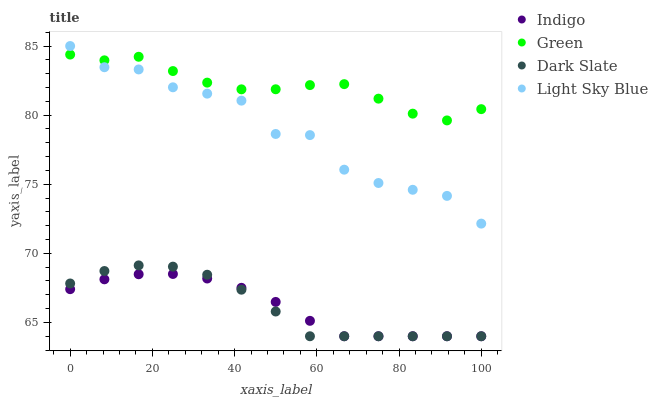Does Indigo have the minimum area under the curve?
Answer yes or no. Yes. Does Green have the maximum area under the curve?
Answer yes or no. Yes. Does Light Sky Blue have the minimum area under the curve?
Answer yes or no. No. Does Light Sky Blue have the maximum area under the curve?
Answer yes or no. No. Is Indigo the smoothest?
Answer yes or no. Yes. Is Light Sky Blue the roughest?
Answer yes or no. Yes. Is Light Sky Blue the smoothest?
Answer yes or no. No. Is Indigo the roughest?
Answer yes or no. No. Does Indigo have the lowest value?
Answer yes or no. Yes. Does Light Sky Blue have the lowest value?
Answer yes or no. No. Does Light Sky Blue have the highest value?
Answer yes or no. Yes. Does Indigo have the highest value?
Answer yes or no. No. Is Dark Slate less than Green?
Answer yes or no. Yes. Is Green greater than Indigo?
Answer yes or no. Yes. Does Light Sky Blue intersect Green?
Answer yes or no. Yes. Is Light Sky Blue less than Green?
Answer yes or no. No. Is Light Sky Blue greater than Green?
Answer yes or no. No. Does Dark Slate intersect Green?
Answer yes or no. No. 